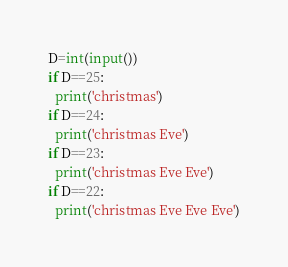Convert code to text. <code><loc_0><loc_0><loc_500><loc_500><_Python_>D=int(input())
if D==25:
  print('christmas')
if D==24:
  print('christmas Eve')
if D==23:
  print('christmas Eve Eve')
if D==22:
  print('christmas Eve Eve Eve')</code> 